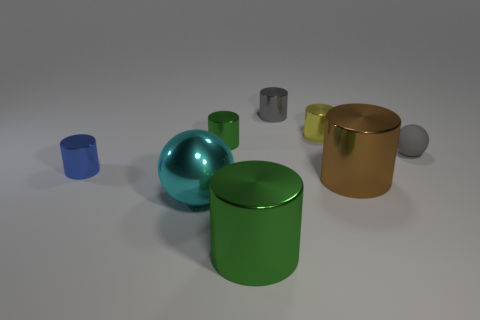Is there anything else that is the same material as the small sphere?
Provide a short and direct response. No. What number of shiny cylinders are the same size as the metal ball?
Provide a succinct answer. 2. Are there fewer large green cylinders behind the small blue shiny thing than green metal objects in front of the cyan thing?
Your answer should be compact. Yes. Are there any purple objects of the same shape as the large green metallic thing?
Give a very brief answer. No. Is the blue thing the same shape as the small matte object?
Your answer should be compact. No. What number of large things are cyan metallic balls or blue matte things?
Provide a succinct answer. 1. Is the number of rubber things greater than the number of small yellow matte cubes?
Offer a very short reply. Yes. What is the size of the brown thing that is made of the same material as the yellow cylinder?
Your answer should be very brief. Large. There is a green cylinder that is to the left of the large green metal object; is its size the same as the ball that is to the left of the tiny matte thing?
Provide a short and direct response. No. What number of things are either tiny objects behind the yellow cylinder or small metallic objects?
Give a very brief answer. 4. 